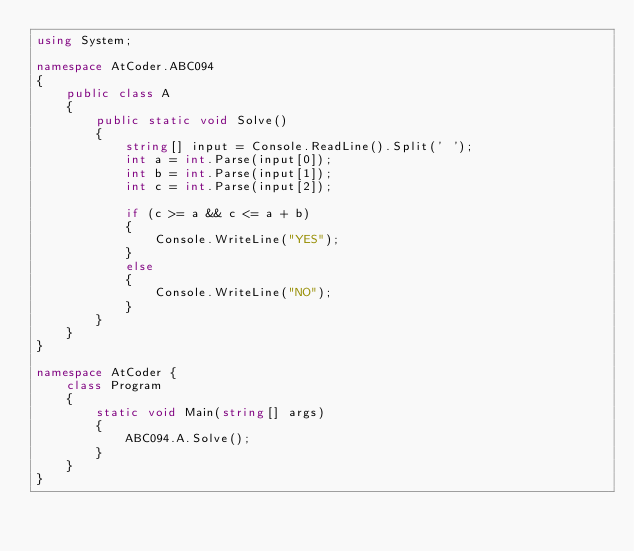Convert code to text. <code><loc_0><loc_0><loc_500><loc_500><_C#_>using System;

namespace AtCoder.ABC094
{
    public class A
    {
        public static void Solve()
        {
            string[] input = Console.ReadLine().Split(' ');
            int a = int.Parse(input[0]);
            int b = int.Parse(input[1]);
            int c = int.Parse(input[2]);

            if (c >= a && c <= a + b)
            {
                Console.WriteLine("YES");
            }
            else
            {
                Console.WriteLine("NO");
            }
        }    
    }
}

namespace AtCoder {
    class Program
    {
        static void Main(string[] args)
        {
            ABC094.A.Solve();
        }
    }
}
</code> 